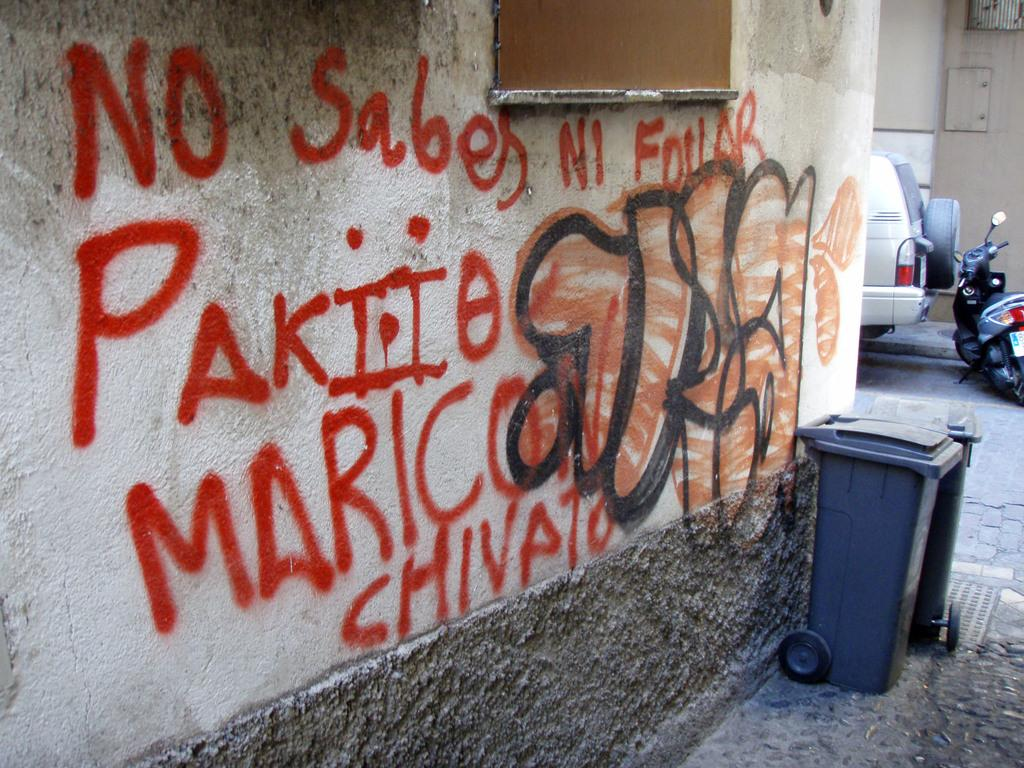<image>
Offer a succinct explanation of the picture presented. graffiti on a wall saying NO SABES Ni Fourar 